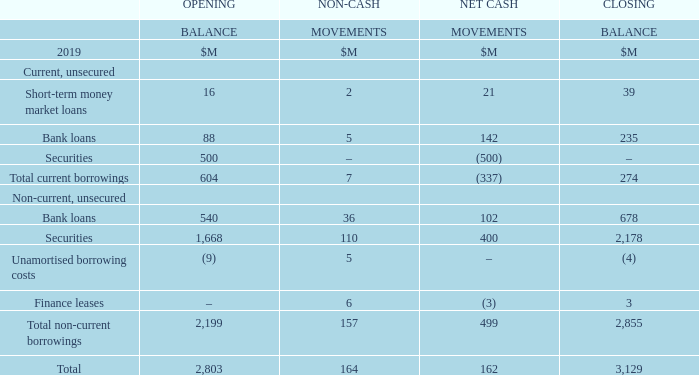This section provides a summary of the capital management activity of the Group during the period, including the Group’s borrowings. The Group manages its liquidity requirements with a range of short-term money market loans, bank loans, and flexible debt instruments with varying maturities.
The Group manages its capital structure with the objective of enhancing long-term shareholder value through funding its business at an optimised weighted average cost of capital.
The Group returns capital to shareholders when consistent with its long-term capital structure objectives and where it will enhance shareholder value. In May 2019, the Group returned $1.7 billion of capital to shareholders through an off-market share buy-back. This resulted in the purchase of 58.7 million shares which were subsequently cancelled. The share buy-back complements dividends of $1.4 billion paid to shareholders this reporting period through the 2018 final and special dividends, and the 2019 interim dividend, with a total of $3.1 billion returned to shareholders, excluding franking credits.
The Group remains committed to solid investment grade credit ratings and a number of actions can be undertaken to support the credit profile including the sale of non-core assets, further working capital initiatives, and adjusting growth capital expenditure and the property leasing profile. The Group’s credit ratings (1) are BBB (stable outlook) according to S&P and Baa2 (stable outlook) according to Moody’s.
In March 2019, the $500 million domestic Medium Term Notes matured. It was refinanced in April 2019 with $400 million of Medium Term Notes issued to meet the Group’s new Green Bond Framework (Green Bonds). The Green Bonds have been issued for a five-year tenor, maturing in April 2024.
In November 2019, $320 million of undrawn syndicated bank loan facilities are due to mature. The Group intends to refinance this facility at maturity.
(1) These credit ratings have been issued by a credit rating agency which holds an Australian Financial Services Licence with an authorisation to issue credit ratings to wholesale clients only and are for the benefit of the Group’s debt providers.
How does the Group manage its liquidity requirements? The group manages its liquidity requirements with a range of short-term money market loans, bank loans, and flexible debt instruments with varying maturities. According to S&P, what is the credit rating for the Group? Bbb. According to Moody's, what is the credit rating for the Group? Baa2. What is the difference between the total opening balance and the total closing balance?
Answer scale should be: million. 3,129 - 2,803 
Answer: 326. What percentage constitution does total non-current borrowings hold in the total opening balance?
Answer scale should be: percent. 2,199/2,803 
Answer: 78.45. What percentage constitution does bank loans hold in total non-current borrowings in the closing balance?
Answer scale should be: percent. 678/2,855 
Answer: 23.75. 